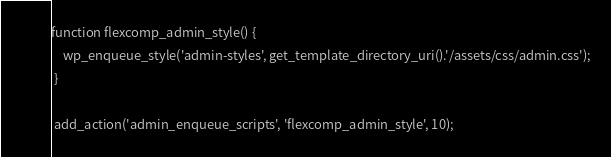<code> <loc_0><loc_0><loc_500><loc_500><_PHP_>

function flexcomp_admin_style() {
    wp_enqueue_style('admin-styles', get_template_directory_uri().'/assets/css/admin.css');
 }
 
 add_action('admin_enqueue_scripts', 'flexcomp_admin_style', 10);</code> 